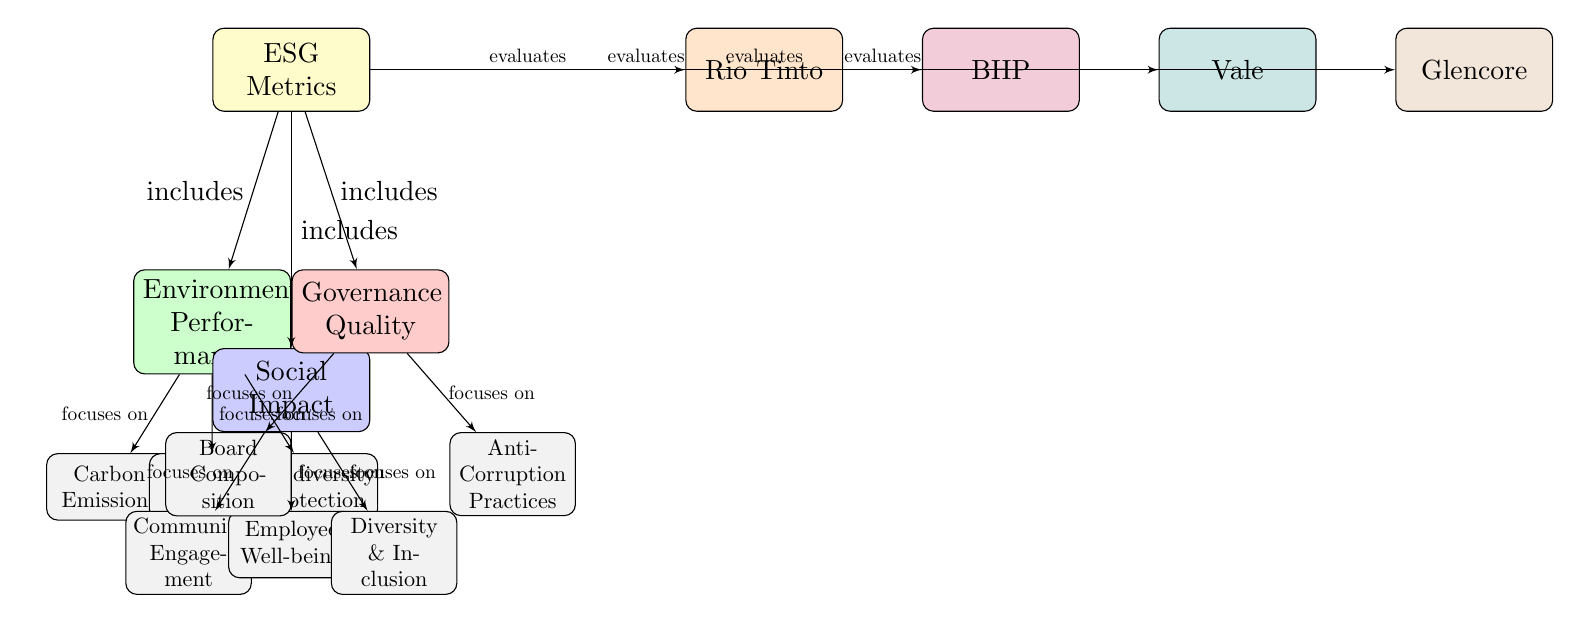What are the three main categories under ESG Metrics in the diagram? The diagram lists three categories branching from ESG Metrics: Environmental Performance, Social Impact, and Governance Quality. This information is straightforwardly derived from the positioning of these categories directly beneath the ESG Metrics node.
Answer: Environmental Performance, Social Impact, Governance Quality Which company is positioned farthest to the right in the diagram? The diagram outlines four companies, with Glencore located farthest to the right. This can be confirmed by tracing the horizontal line from ESG Metrics to the companies listed, where Glencore is the last one.
Answer: Glencore How many subcategories are under Environmental Performance? Under Environmental Performance, the diagram displays three subcategories: Carbon Emissions, Water Usage, and Biodiversity Protection. Each of these is visually represented in boxes directly beneath the Environmental Performance node.
Answer: 3 What does Governance Quality focus on according to the diagram? Governance Quality focuses on two specific subcategories according to the diagram: Board Composition and Anti-Corruption Practices. This is evident as these nodes are connected directly to the Governance Quality node via arrows indicating their focus.
Answer: Board Composition, Anti-Corruption Practices Which social aspect does the diagram include related to employee welfare? The diagram includes Employee Well-being as a specific focus area under the Social Impact category. This is directly represented in the diagram where an arrow connects Social Impact to Employee Well-being.
Answer: Employee Well-being What color represents the Environmental Performance category in the diagram? The Environmental Performance category is filled with a greenish hue as indicated within the diagram labels. Looking at the color coding for each category provides this answer.
Answer: Green How many companies are evaluated in the context of ESG Metrics according to the diagram? The diagram shows a total of four companies: Rio Tinto, BHP, Vale, and Glencore all evaluated under the ESG Metrics. This count can be confirmed by counting the blocks representing companies connected to the ESG Metrics node.
Answer: 4 What is the focus area directly connected to the Community Engagement subcategory? Community Engagement focuses on social aspects, specifically representing a connection related to social performance evaluations in mining companies. The diagram illustrates it connected to the Social Impact node.
Answer: Community Engagement What central theme does the ESG Metrics node represent in the diagram? The central theme represented by the ESG Metrics node is the evaluation of companies based on their Environmental, Social, and Governance performance. It explicitly branches into these three categories, indicating the overall focus of the diagram is on these aspects of corporate sustainability.
Answer: Evaluation of companies based on ESG performance 